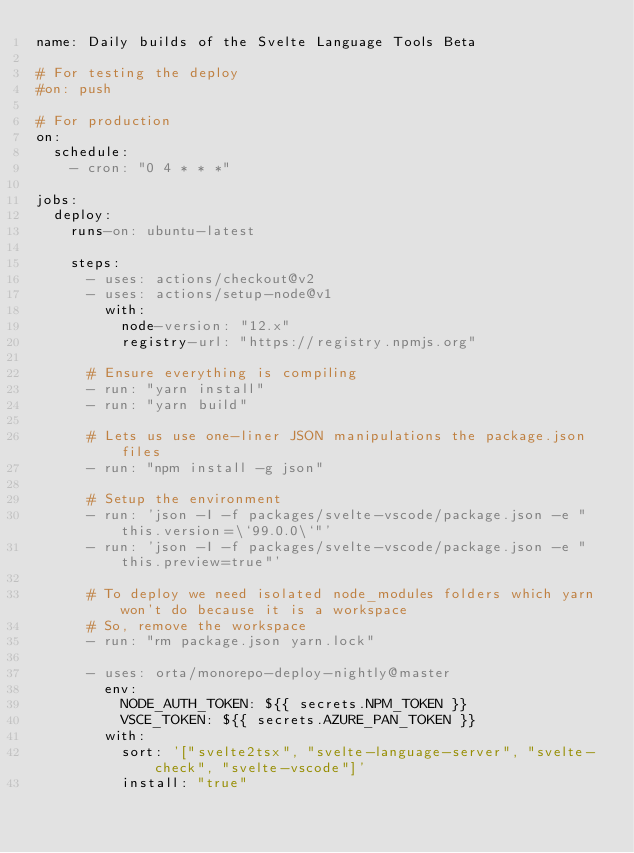Convert code to text. <code><loc_0><loc_0><loc_500><loc_500><_YAML_>name: Daily builds of the Svelte Language Tools Beta

# For testing the deploy
#on: push

# For production
on:
  schedule:
    - cron: "0 4 * * *"

jobs:
  deploy:
    runs-on: ubuntu-latest

    steps:
      - uses: actions/checkout@v2
      - uses: actions/setup-node@v1
        with:
          node-version: "12.x"
          registry-url: "https://registry.npmjs.org"

      # Ensure everything is compiling
      - run: "yarn install"
      - run: "yarn build"

      # Lets us use one-liner JSON manipulations the package.json files
      - run: "npm install -g json"

      # Setup the environment
      - run: 'json -I -f packages/svelte-vscode/package.json -e "this.version=\`99.0.0\`"'
      - run: 'json -I -f packages/svelte-vscode/package.json -e "this.preview=true"'

      # To deploy we need isolated node_modules folders which yarn won't do because it is a workspace
      # So, remove the workspace
      - run: "rm package.json yarn.lock"

      - uses: orta/monorepo-deploy-nightly@master
        env:
          NODE_AUTH_TOKEN: ${{ secrets.NPM_TOKEN }}
          VSCE_TOKEN: ${{ secrets.AZURE_PAN_TOKEN }}
        with: 
          sort: '["svelte2tsx", "svelte-language-server", "svelte-check", "svelte-vscode"]'
          install: "true"
</code> 